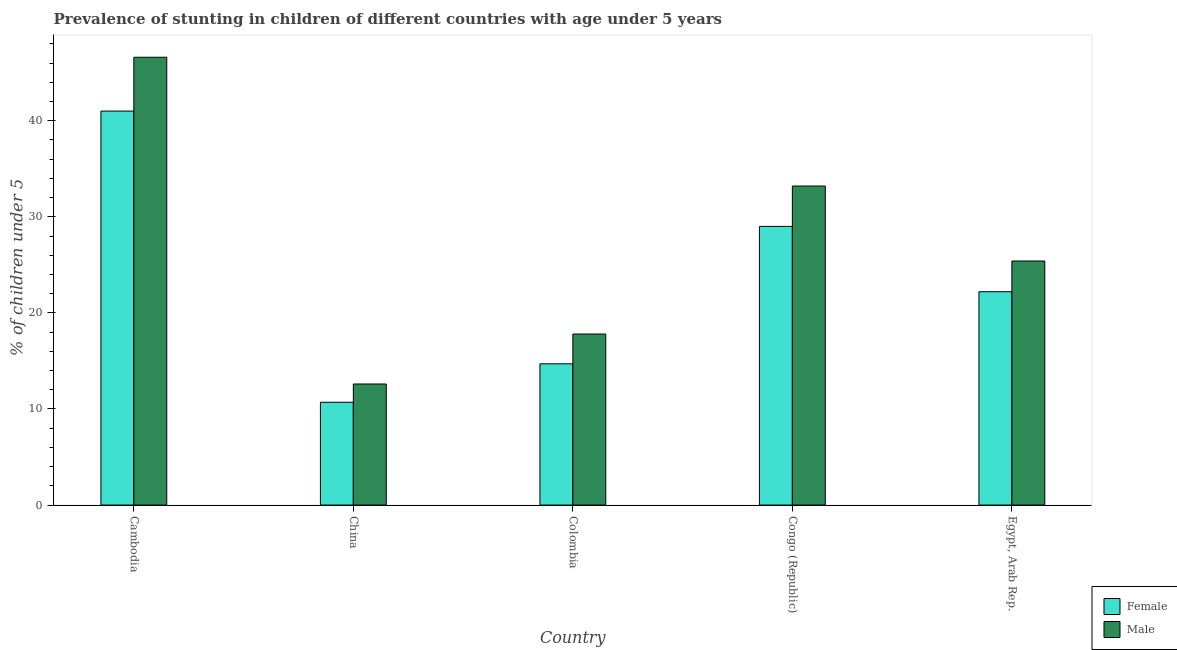How many bars are there on the 2nd tick from the left?
Offer a terse response. 2. What is the label of the 4th group of bars from the left?
Provide a succinct answer. Congo (Republic). In how many cases, is the number of bars for a given country not equal to the number of legend labels?
Make the answer very short. 0. What is the percentage of stunted female children in Colombia?
Give a very brief answer. 14.7. Across all countries, what is the maximum percentage of stunted male children?
Give a very brief answer. 46.6. Across all countries, what is the minimum percentage of stunted male children?
Make the answer very short. 12.6. In which country was the percentage of stunted male children maximum?
Your response must be concise. Cambodia. What is the total percentage of stunted male children in the graph?
Your answer should be very brief. 135.6. What is the difference between the percentage of stunted male children in Colombia and that in Congo (Republic)?
Provide a succinct answer. -15.4. What is the difference between the percentage of stunted male children in Colombia and the percentage of stunted female children in Egypt, Arab Rep.?
Your answer should be very brief. -4.4. What is the average percentage of stunted female children per country?
Keep it short and to the point. 23.52. What is the difference between the percentage of stunted male children and percentage of stunted female children in Egypt, Arab Rep.?
Your answer should be compact. 3.2. In how many countries, is the percentage of stunted male children greater than 6 %?
Ensure brevity in your answer.  5. What is the ratio of the percentage of stunted male children in China to that in Colombia?
Make the answer very short. 0.71. Is the difference between the percentage of stunted female children in Congo (Republic) and Egypt, Arab Rep. greater than the difference between the percentage of stunted male children in Congo (Republic) and Egypt, Arab Rep.?
Provide a short and direct response. No. What is the difference between the highest and the second highest percentage of stunted male children?
Offer a terse response. 13.4. What is the difference between the highest and the lowest percentage of stunted male children?
Make the answer very short. 34. What does the 1st bar from the left in Egypt, Arab Rep. represents?
Your answer should be very brief. Female. How many bars are there?
Keep it short and to the point. 10. Are all the bars in the graph horizontal?
Your response must be concise. No. Are the values on the major ticks of Y-axis written in scientific E-notation?
Make the answer very short. No. Does the graph contain any zero values?
Your answer should be compact. No. Where does the legend appear in the graph?
Your answer should be very brief. Bottom right. How many legend labels are there?
Keep it short and to the point. 2. How are the legend labels stacked?
Your response must be concise. Vertical. What is the title of the graph?
Provide a short and direct response. Prevalence of stunting in children of different countries with age under 5 years. What is the label or title of the Y-axis?
Offer a very short reply.  % of children under 5. What is the  % of children under 5 of Female in Cambodia?
Offer a terse response. 41. What is the  % of children under 5 of Male in Cambodia?
Your answer should be very brief. 46.6. What is the  % of children under 5 in Female in China?
Offer a terse response. 10.7. What is the  % of children under 5 of Male in China?
Offer a terse response. 12.6. What is the  % of children under 5 of Female in Colombia?
Ensure brevity in your answer.  14.7. What is the  % of children under 5 in Male in Colombia?
Provide a succinct answer. 17.8. What is the  % of children under 5 in Male in Congo (Republic)?
Ensure brevity in your answer.  33.2. What is the  % of children under 5 in Female in Egypt, Arab Rep.?
Offer a terse response. 22.2. What is the  % of children under 5 in Male in Egypt, Arab Rep.?
Your answer should be compact. 25.4. Across all countries, what is the maximum  % of children under 5 of Male?
Your answer should be very brief. 46.6. Across all countries, what is the minimum  % of children under 5 in Female?
Your answer should be compact. 10.7. Across all countries, what is the minimum  % of children under 5 of Male?
Provide a short and direct response. 12.6. What is the total  % of children under 5 of Female in the graph?
Provide a succinct answer. 117.6. What is the total  % of children under 5 of Male in the graph?
Provide a succinct answer. 135.6. What is the difference between the  % of children under 5 of Female in Cambodia and that in China?
Keep it short and to the point. 30.3. What is the difference between the  % of children under 5 of Female in Cambodia and that in Colombia?
Give a very brief answer. 26.3. What is the difference between the  % of children under 5 in Male in Cambodia and that in Colombia?
Provide a succinct answer. 28.8. What is the difference between the  % of children under 5 in Male in Cambodia and that in Congo (Republic)?
Offer a very short reply. 13.4. What is the difference between the  % of children under 5 of Female in Cambodia and that in Egypt, Arab Rep.?
Offer a very short reply. 18.8. What is the difference between the  % of children under 5 of Male in Cambodia and that in Egypt, Arab Rep.?
Your response must be concise. 21.2. What is the difference between the  % of children under 5 of Female in China and that in Congo (Republic)?
Your response must be concise. -18.3. What is the difference between the  % of children under 5 in Male in China and that in Congo (Republic)?
Provide a succinct answer. -20.6. What is the difference between the  % of children under 5 of Female in China and that in Egypt, Arab Rep.?
Keep it short and to the point. -11.5. What is the difference between the  % of children under 5 of Female in Colombia and that in Congo (Republic)?
Provide a short and direct response. -14.3. What is the difference between the  % of children under 5 in Male in Colombia and that in Congo (Republic)?
Give a very brief answer. -15.4. What is the difference between the  % of children under 5 of Male in Colombia and that in Egypt, Arab Rep.?
Your response must be concise. -7.6. What is the difference between the  % of children under 5 in Female in Congo (Republic) and that in Egypt, Arab Rep.?
Give a very brief answer. 6.8. What is the difference between the  % of children under 5 of Male in Congo (Republic) and that in Egypt, Arab Rep.?
Give a very brief answer. 7.8. What is the difference between the  % of children under 5 in Female in Cambodia and the  % of children under 5 in Male in China?
Offer a terse response. 28.4. What is the difference between the  % of children under 5 of Female in Cambodia and the  % of children under 5 of Male in Colombia?
Your answer should be very brief. 23.2. What is the difference between the  % of children under 5 of Female in Cambodia and the  % of children under 5 of Male in Egypt, Arab Rep.?
Your response must be concise. 15.6. What is the difference between the  % of children under 5 in Female in China and the  % of children under 5 in Male in Colombia?
Your response must be concise. -7.1. What is the difference between the  % of children under 5 of Female in China and the  % of children under 5 of Male in Congo (Republic)?
Your answer should be compact. -22.5. What is the difference between the  % of children under 5 in Female in China and the  % of children under 5 in Male in Egypt, Arab Rep.?
Give a very brief answer. -14.7. What is the difference between the  % of children under 5 in Female in Colombia and the  % of children under 5 in Male in Congo (Republic)?
Offer a very short reply. -18.5. What is the difference between the  % of children under 5 in Female in Congo (Republic) and the  % of children under 5 in Male in Egypt, Arab Rep.?
Give a very brief answer. 3.6. What is the average  % of children under 5 of Female per country?
Offer a terse response. 23.52. What is the average  % of children under 5 in Male per country?
Provide a succinct answer. 27.12. What is the difference between the  % of children under 5 in Female and  % of children under 5 in Male in Cambodia?
Provide a short and direct response. -5.6. What is the difference between the  % of children under 5 in Female and  % of children under 5 in Male in China?
Keep it short and to the point. -1.9. What is the difference between the  % of children under 5 of Female and  % of children under 5 of Male in Congo (Republic)?
Your answer should be compact. -4.2. What is the difference between the  % of children under 5 of Female and  % of children under 5 of Male in Egypt, Arab Rep.?
Offer a very short reply. -3.2. What is the ratio of the  % of children under 5 in Female in Cambodia to that in China?
Make the answer very short. 3.83. What is the ratio of the  % of children under 5 in Male in Cambodia to that in China?
Offer a very short reply. 3.7. What is the ratio of the  % of children under 5 in Female in Cambodia to that in Colombia?
Make the answer very short. 2.79. What is the ratio of the  % of children under 5 in Male in Cambodia to that in Colombia?
Your answer should be very brief. 2.62. What is the ratio of the  % of children under 5 of Female in Cambodia to that in Congo (Republic)?
Offer a very short reply. 1.41. What is the ratio of the  % of children under 5 in Male in Cambodia to that in Congo (Republic)?
Provide a succinct answer. 1.4. What is the ratio of the  % of children under 5 of Female in Cambodia to that in Egypt, Arab Rep.?
Your answer should be very brief. 1.85. What is the ratio of the  % of children under 5 in Male in Cambodia to that in Egypt, Arab Rep.?
Provide a succinct answer. 1.83. What is the ratio of the  % of children under 5 in Female in China to that in Colombia?
Make the answer very short. 0.73. What is the ratio of the  % of children under 5 in Male in China to that in Colombia?
Ensure brevity in your answer.  0.71. What is the ratio of the  % of children under 5 in Female in China to that in Congo (Republic)?
Your answer should be very brief. 0.37. What is the ratio of the  % of children under 5 in Male in China to that in Congo (Republic)?
Provide a succinct answer. 0.38. What is the ratio of the  % of children under 5 of Female in China to that in Egypt, Arab Rep.?
Make the answer very short. 0.48. What is the ratio of the  % of children under 5 in Male in China to that in Egypt, Arab Rep.?
Offer a very short reply. 0.5. What is the ratio of the  % of children under 5 of Female in Colombia to that in Congo (Republic)?
Keep it short and to the point. 0.51. What is the ratio of the  % of children under 5 in Male in Colombia to that in Congo (Republic)?
Ensure brevity in your answer.  0.54. What is the ratio of the  % of children under 5 of Female in Colombia to that in Egypt, Arab Rep.?
Your answer should be compact. 0.66. What is the ratio of the  % of children under 5 in Male in Colombia to that in Egypt, Arab Rep.?
Keep it short and to the point. 0.7. What is the ratio of the  % of children under 5 in Female in Congo (Republic) to that in Egypt, Arab Rep.?
Your answer should be compact. 1.31. What is the ratio of the  % of children under 5 of Male in Congo (Republic) to that in Egypt, Arab Rep.?
Your answer should be compact. 1.31. What is the difference between the highest and the second highest  % of children under 5 of Female?
Keep it short and to the point. 12. What is the difference between the highest and the lowest  % of children under 5 in Female?
Ensure brevity in your answer.  30.3. What is the difference between the highest and the lowest  % of children under 5 in Male?
Your answer should be very brief. 34. 